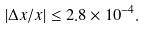<formula> <loc_0><loc_0><loc_500><loc_500>| \Delta x / x | \leq 2 . 8 \times 1 0 ^ { - 4 } .</formula> 